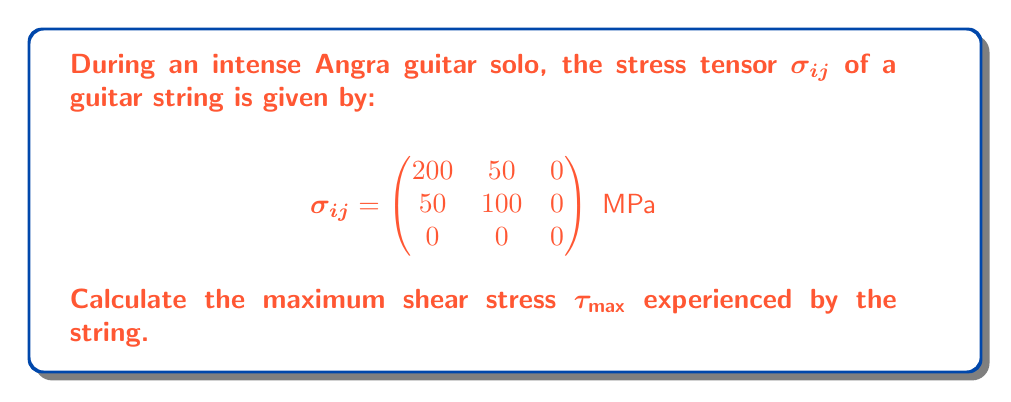Show me your answer to this math problem. To find the maximum shear stress, we'll follow these steps:

1) First, we need to find the principal stresses. For a 2D stress state (since $\sigma_{33} = 0$), we can use the following formula:

   $$\sigma_{1,2} = \frac{\sigma_{11} + \sigma_{22}}{2} \pm \sqrt{\left(\frac{\sigma_{11} - \sigma_{22}}{2}\right)^2 + \sigma_{12}^2}$$

2) Substituting the values:
   
   $$\sigma_{1,2} = \frac{200 + 100}{2} \pm \sqrt{\left(\frac{200 - 100}{2}\right)^2 + 50^2}$$

3) Simplifying:
   
   $$\sigma_{1,2} = 150 \pm \sqrt{2500 + 2500} = 150 \pm \sqrt{5000} = 150 \pm 70.71$$

4) Therefore:
   
   $\sigma_1 = 220.71$ MPa
   $\sigma_2 = 79.29$ MPa
   $\sigma_3 = 0$ MPa (since it's a 2D stress state)

5) The maximum shear stress is given by:

   $$\tau_{\text{max}} = \frac{\sigma_1 - \sigma_3}{2}$$

6) Substituting the values:

   $$\tau_{\text{max}} = \frac{220.71 - 0}{2} = 110.355 \text{ MPa}$$
Answer: $110.355 \text{ MPa}$ 